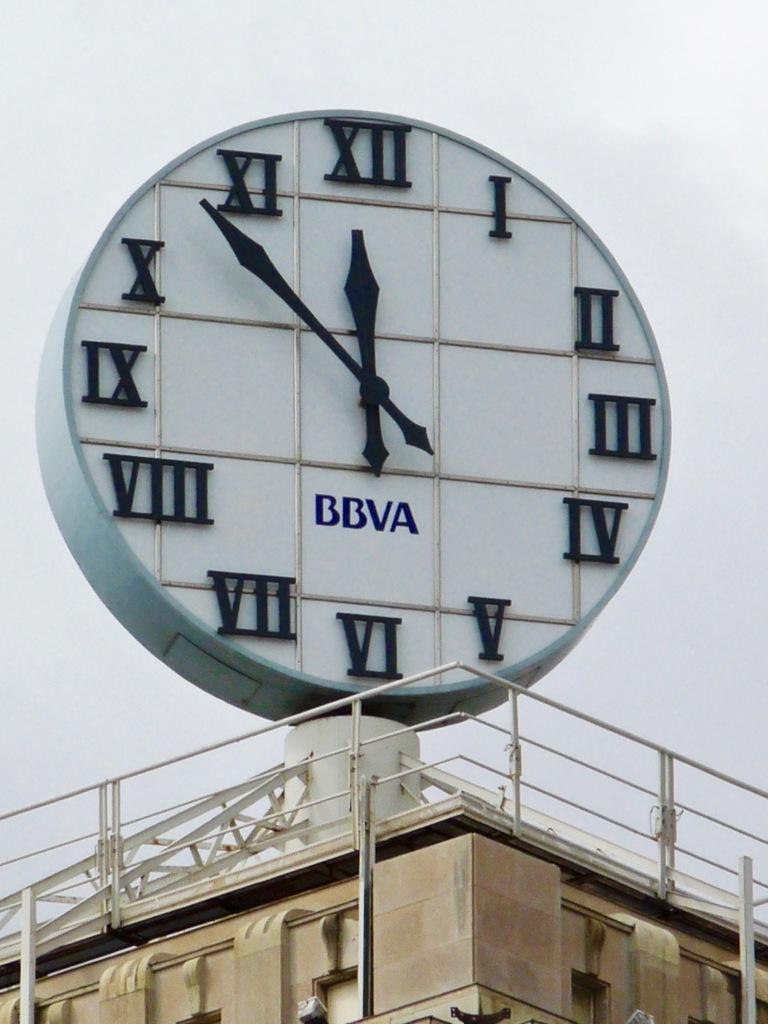What time is it in madrid at the moment?
Offer a terse response. 11:53. What four letters are on the clock face?
Provide a short and direct response. Bbva. 